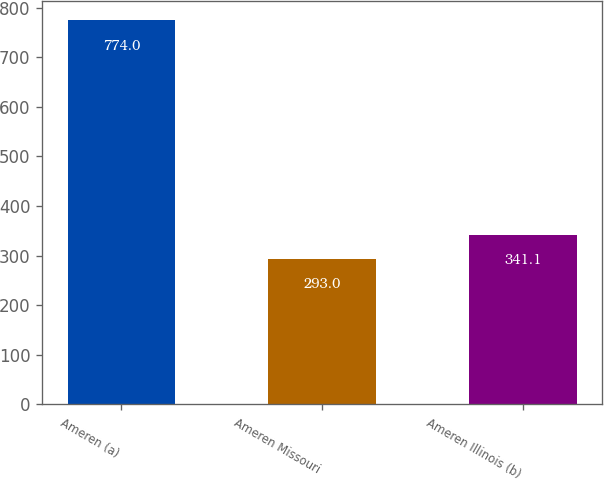Convert chart. <chart><loc_0><loc_0><loc_500><loc_500><bar_chart><fcel>Ameren (a)<fcel>Ameren Missouri<fcel>Ameren Illinois (b)<nl><fcel>774<fcel>293<fcel>341.1<nl></chart> 